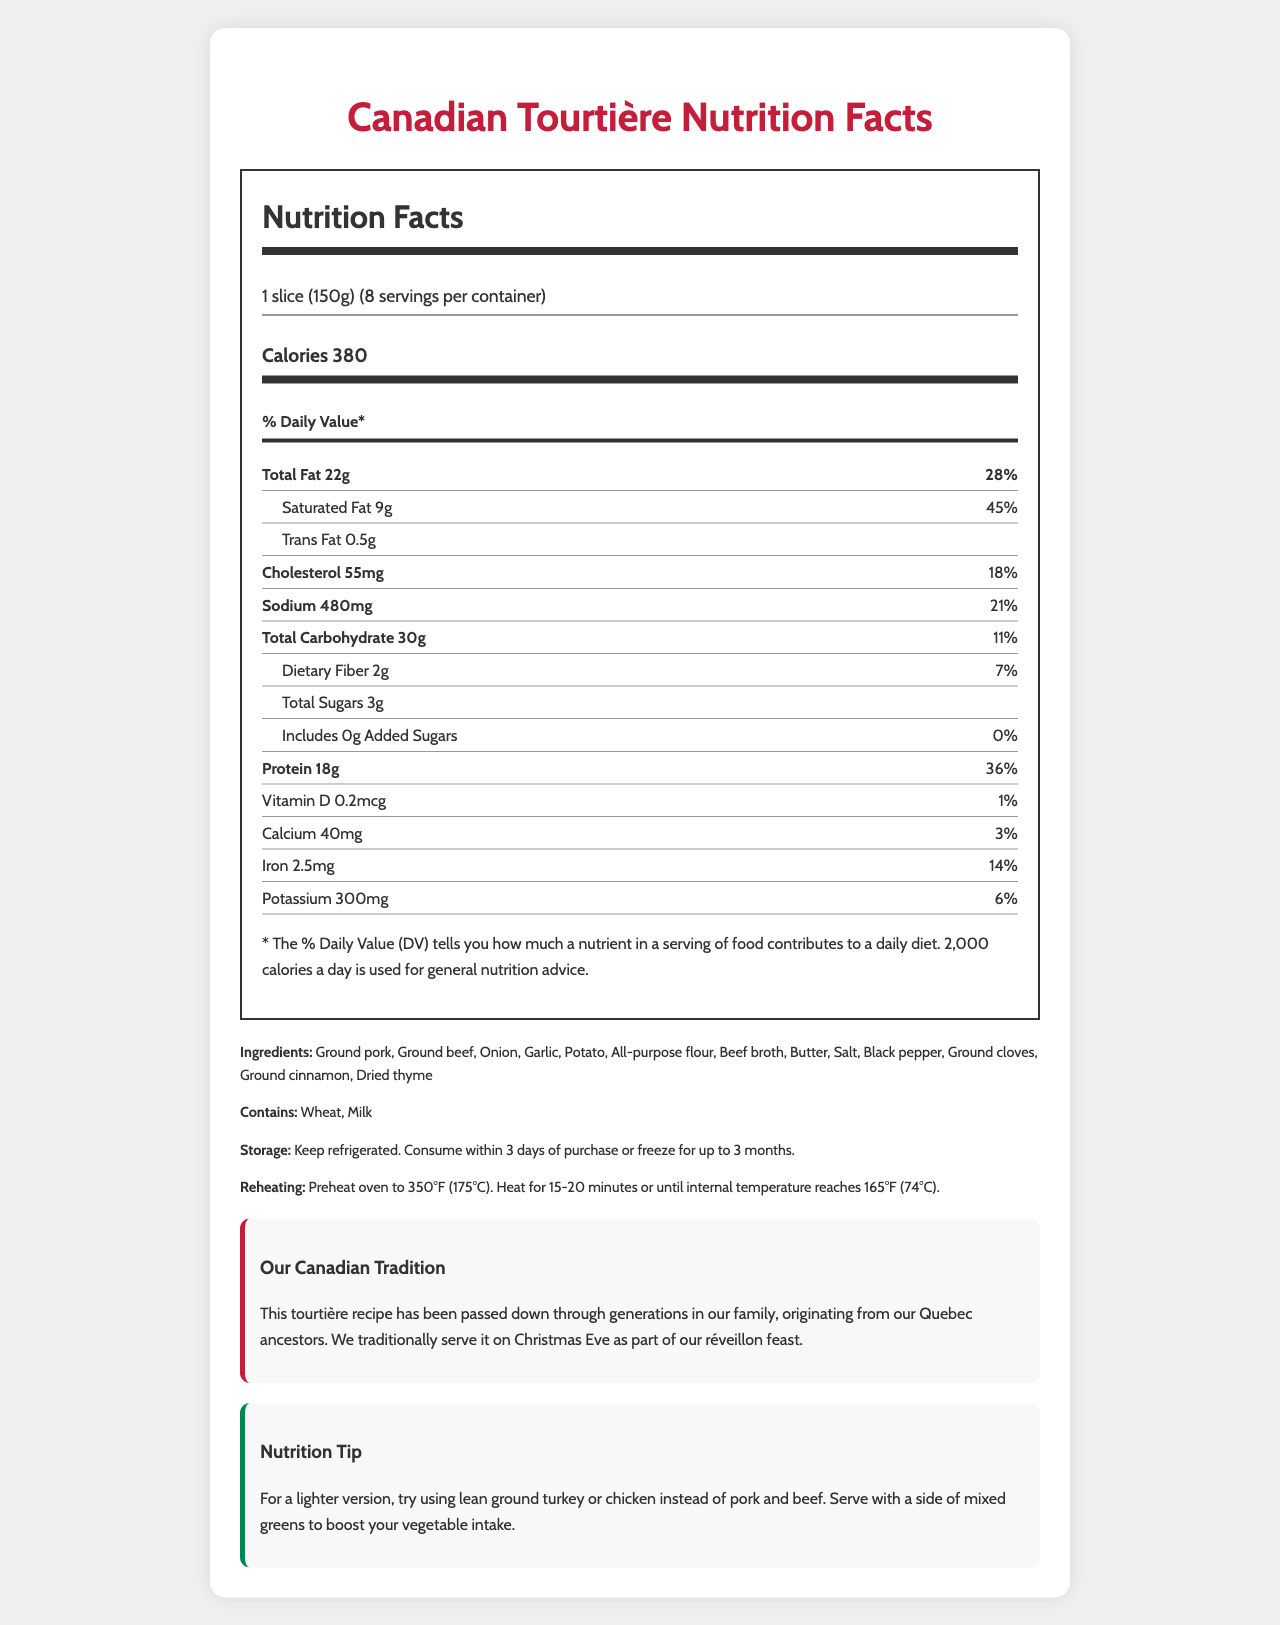what is the serving size of the Canadian Tourtière meat pie? The serving size is directly listed as "1 slice (150g)" in the document.
Answer: 1 slice (150g) how many calories are in one serving of the tourtière? The calories per serving are stated as "Calories 380."
Answer: 380 what is the percentage of daily value of protein in one slice? The document states "Protein 18g" and "36% Daily Value" for protein.
Answer: 36% list three ingredients found in the tourtière. The ingredients list includes "Ground pork, Ground beef, Onion," and others.
Answer: Ground pork, Ground beef, Onion how long can you keep the tourtière in the freezer? The storage instructions state to "consume within 3 days of purchase or freeze for up to 3 months."
Answer: Up to 3 months how much sodium is in one serving? The amount of sodium per serving is listed as "Sodium 480mg."
Answer: 480mg which of the following nutrients has the highest daily value percentage: iron, calcium, or vitamin D? The daily value percentages are: Iron 14%, Calcium 3%, and Vitamin D 1%. Therefore, Iron has the highest daily value percentage.
Answer: Iron what are the allergens present in the tourtière? The document lists the allergens as "Wheat, Milk."
Answer: Wheat, Milk which of the following is a suggested alternative to make a lighter version of the tourtière? A. Using ground pork B. Using lean ground turkey C. Adding more butter D. Increasing salt The nutrition tip suggests "try using lean ground turkey or chicken instead of pork and beef."
Answer: B per the tradition, when is the tourtière typically served? A. Thanksgiving B. Christmas Eve C. New Year’s Day D. Easter The tradition section mentions it is served on "Christmas Eve."
Answer: B is trans fat present in the tourtière? The label lists "Trans Fat 0.5g," indicating its presence.
Answer: Yes does the tourtière have any added sugars? The document states "Includes 0g Added Sugars," indicating no added sugars.
Answer: No summarize the main idea of the document The document is a comprehensive guide to the nutrition, preparation, and traditional significance of the Canadian Tourtière meat pie, highlighting its caloric content, protein, and allergens.
Answer: The document provides the nutrition facts, ingredients, allergens, storage and reheating instructions, a family tradition, and a nutrition tip about a Canadian Tourtière meat pie. The pie is traditionally served on Christmas Eve and includes both pork and beef, alongside various herbs and spices. what is the fat content of the tourtière? There is no specific section in the document that consolidates the "fat content" of the tourtière; one would need to refer to the individual fat sub-categories like total fat and trans fat.
Answer: Not enough information 